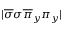<formula> <loc_0><loc_0><loc_500><loc_500>| \overline { \sigma } \sigma \overline { \pi } _ { y } \pi _ { y } |</formula> 